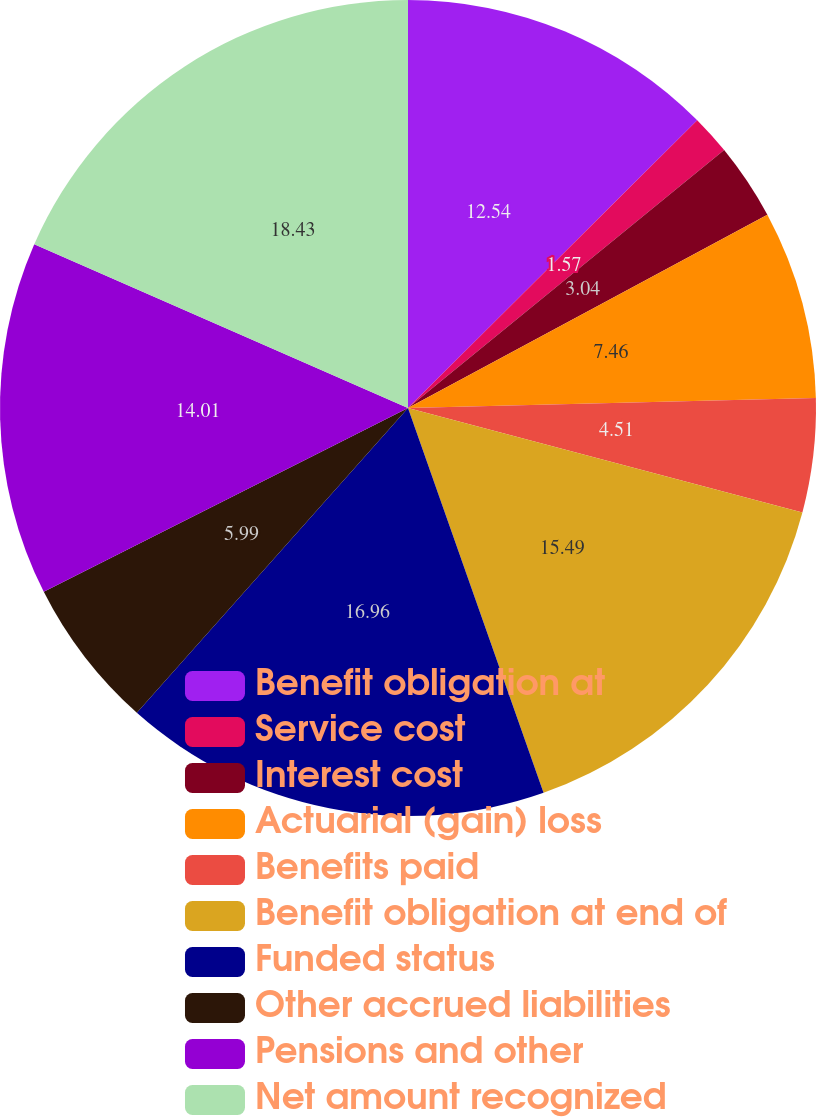Convert chart to OTSL. <chart><loc_0><loc_0><loc_500><loc_500><pie_chart><fcel>Benefit obligation at<fcel>Service cost<fcel>Interest cost<fcel>Actuarial (gain) loss<fcel>Benefits paid<fcel>Benefit obligation at end of<fcel>Funded status<fcel>Other accrued liabilities<fcel>Pensions and other<fcel>Net amount recognized<nl><fcel>12.54%<fcel>1.57%<fcel>3.04%<fcel>7.46%<fcel>4.51%<fcel>15.49%<fcel>16.96%<fcel>5.99%<fcel>14.01%<fcel>18.43%<nl></chart> 